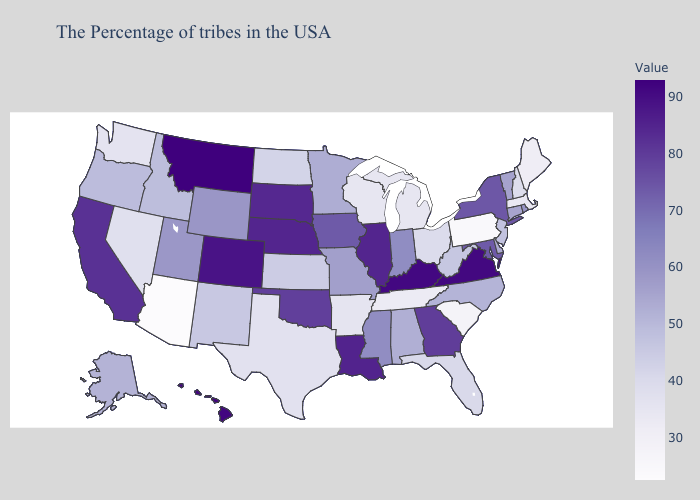Does Washington have a lower value than Arizona?
Be succinct. No. Does Idaho have a higher value than Ohio?
Answer briefly. Yes. 